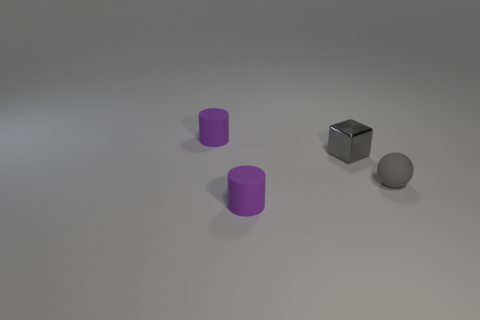There is a small gray ball; are there any matte things behind it?
Provide a short and direct response. Yes. What color is the small matte cylinder that is behind the tiny gray block?
Offer a terse response. Purple. What is the material of the gray block behind the tiny gray object that is in front of the metallic block?
Your answer should be compact. Metal. Is the number of purple things that are in front of the gray metal thing less than the number of tiny gray objects in front of the small gray rubber object?
Give a very brief answer. No. What number of blue things are either matte cylinders or blocks?
Provide a short and direct response. 0. Are there an equal number of small gray metal blocks that are in front of the tiny gray sphere and small purple cylinders?
Provide a short and direct response. No. What number of things are either purple objects or gray things on the right side of the small gray shiny object?
Offer a terse response. 3. Does the tiny metal cube have the same color as the tiny sphere?
Keep it short and to the point. Yes. Is there a gray ball made of the same material as the cube?
Provide a short and direct response. No. Is the small sphere made of the same material as the tiny cylinder behind the shiny thing?
Offer a very short reply. Yes. 